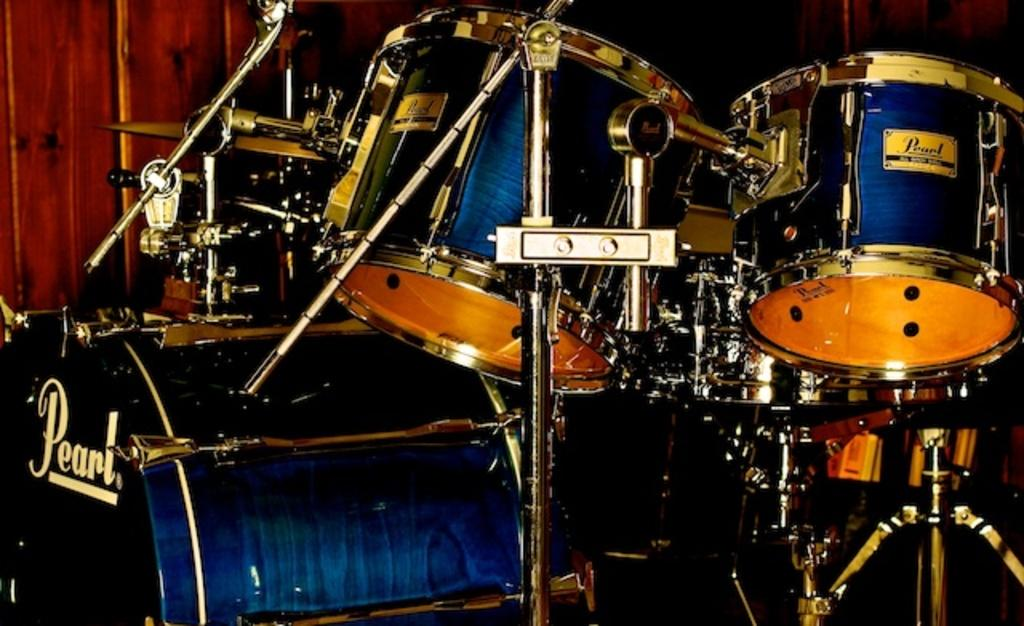What type of musical instrument is featured in the image? There is a drum kit in the image. What are the main components of the drum kit? The drum kit has rods and drums. Can you describe the wooden object in the background of the image? Unfortunately, the facts provided do not give any information about the wooden object in the background. How many ladybugs are crawling on the drums in the image? There are no ladybugs present in the image; it features a drum kit with rods and drums. What type of juice is being served in the image? There is no juice present in the image; it features a drum kit with rods and drums. 